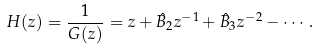Convert formula to latex. <formula><loc_0><loc_0><loc_500><loc_500>H ( z ) = \frac { 1 } { G ( z ) } = z + \hat { B } _ { 2 } z ^ { - 1 } + \hat { B } _ { 3 } z ^ { - 2 } - \cdots .</formula> 